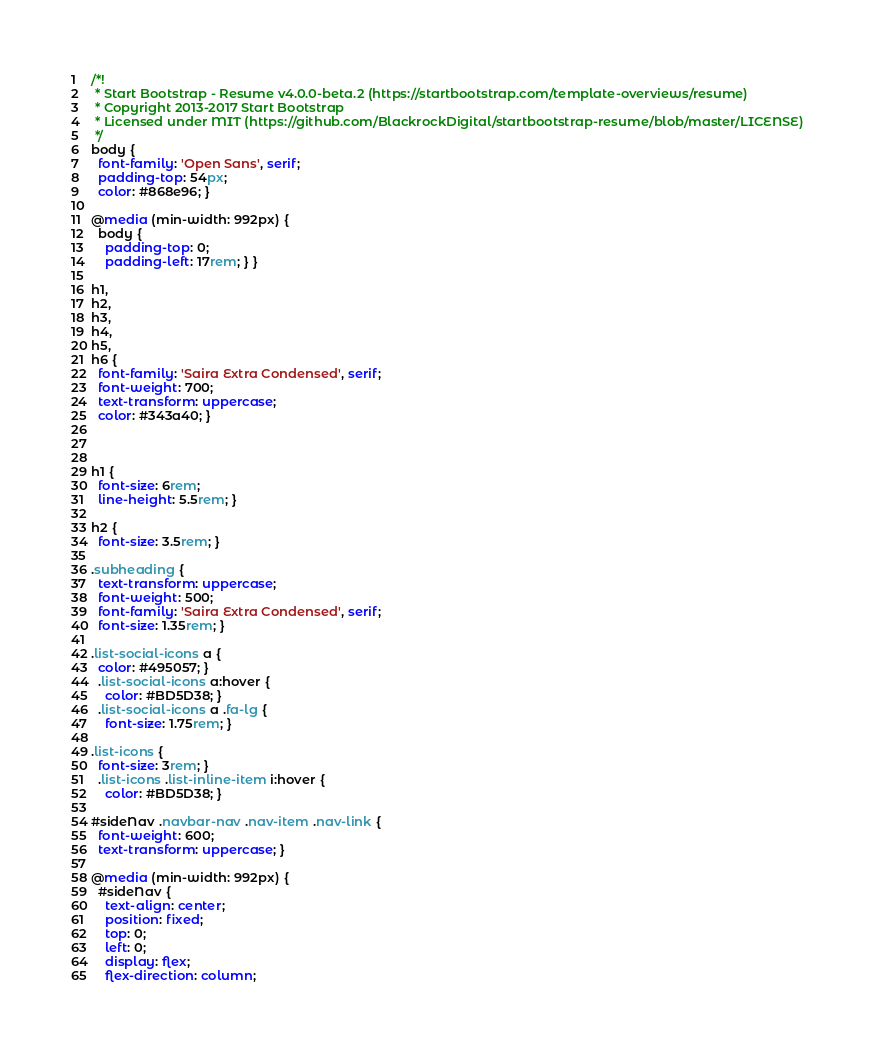<code> <loc_0><loc_0><loc_500><loc_500><_CSS_>/*!
 * Start Bootstrap - Resume v4.0.0-beta.2 (https://startbootstrap.com/template-overviews/resume)
 * Copyright 2013-2017 Start Bootstrap
 * Licensed under MIT (https://github.com/BlackrockDigital/startbootstrap-resume/blob/master/LICENSE)
 */
body {
  font-family: 'Open Sans', serif;
  padding-top: 54px;
  color: #868e96; }

@media (min-width: 992px) {
  body {
    padding-top: 0;
    padding-left: 17rem; } }

h1,
h2,
h3,
h4,
h5,
h6 {
  font-family: 'Saira Extra Condensed', serif;
  font-weight: 700;
  text-transform: uppercase;
  color: #343a40; }



h1 {
  font-size: 6rem;
  line-height: 5.5rem; }

h2 {
  font-size: 3.5rem; }

.subheading {
  text-transform: uppercase;
  font-weight: 500;
  font-family: 'Saira Extra Condensed', serif;
  font-size: 1.35rem; }

.list-social-icons a {
  color: #495057; }
  .list-social-icons a:hover {
    color: #BD5D38; }
  .list-social-icons a .fa-lg {
    font-size: 1.75rem; }

.list-icons {
  font-size: 3rem; }
  .list-icons .list-inline-item i:hover {
    color: #BD5D38; }

#sideNav .navbar-nav .nav-item .nav-link {
  font-weight: 600;
  text-transform: uppercase; }

@media (min-width: 992px) {
  #sideNav {
    text-align: center;
    position: fixed;
    top: 0;
    left: 0;
    display: flex;
    flex-direction: column;</code> 